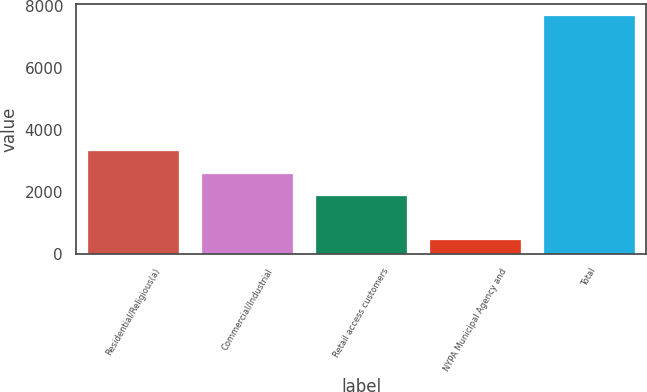Convert chart. <chart><loc_0><loc_0><loc_500><loc_500><bar_chart><fcel>Residential/Religious(a)<fcel>Commercial/Industrial<fcel>Retail access customers<fcel>NYPA Municipal Agency and<fcel>Total<nl><fcel>3298.4<fcel>2576.7<fcel>1855<fcel>457<fcel>7674<nl></chart> 